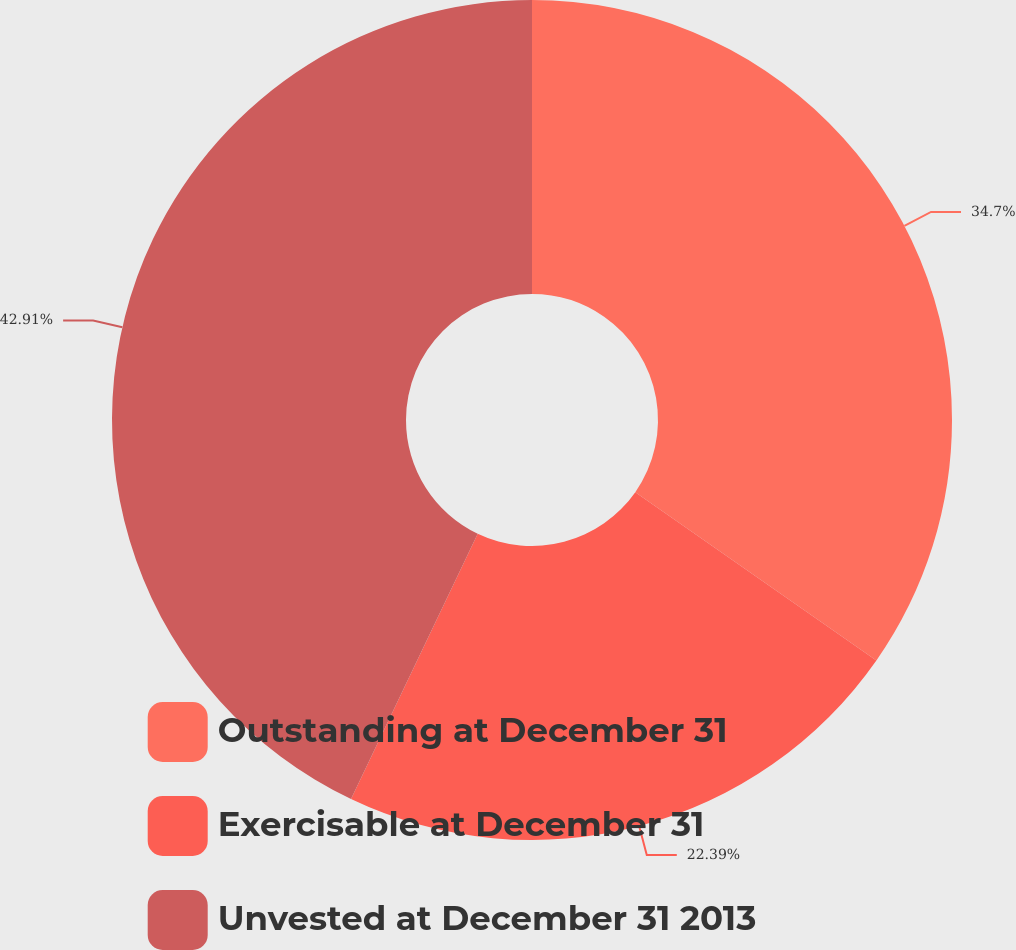<chart> <loc_0><loc_0><loc_500><loc_500><pie_chart><fcel>Outstanding at December 31<fcel>Exercisable at December 31<fcel>Unvested at December 31 2013<nl><fcel>34.7%<fcel>22.39%<fcel>42.91%<nl></chart> 